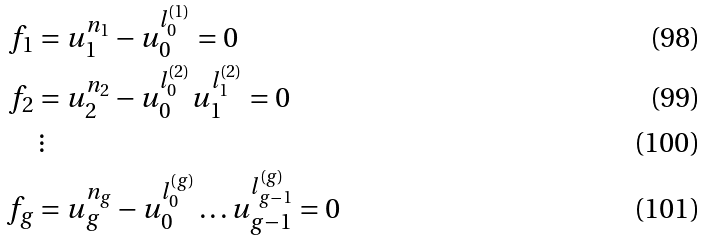<formula> <loc_0><loc_0><loc_500><loc_500>f _ { 1 } & = u _ { 1 } ^ { n _ { 1 } } - u _ { 0 } ^ { l _ { 0 } ^ { ( 1 ) } } = 0 \\ f _ { 2 } & = u _ { 2 } ^ { n _ { 2 } } - u _ { 0 } ^ { l _ { 0 } ^ { ( 2 ) } } u _ { 1 } ^ { l _ { 1 } ^ { ( 2 ) } } = 0 \\ & \, \vdots \\ f _ { g } & = u _ { g } ^ { n _ { g } } - u _ { 0 } ^ { l _ { 0 } ^ { ( g ) } } \dots u _ { g - 1 } ^ { l _ { g - 1 } ^ { ( g ) } } = 0</formula> 